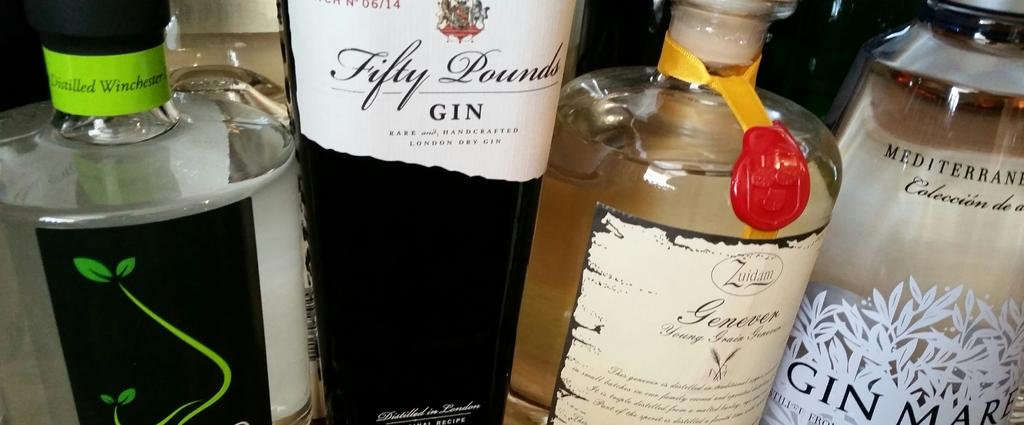Provide a one-sentence caption for the provided image. Four different bottles of gin are available to drink. 